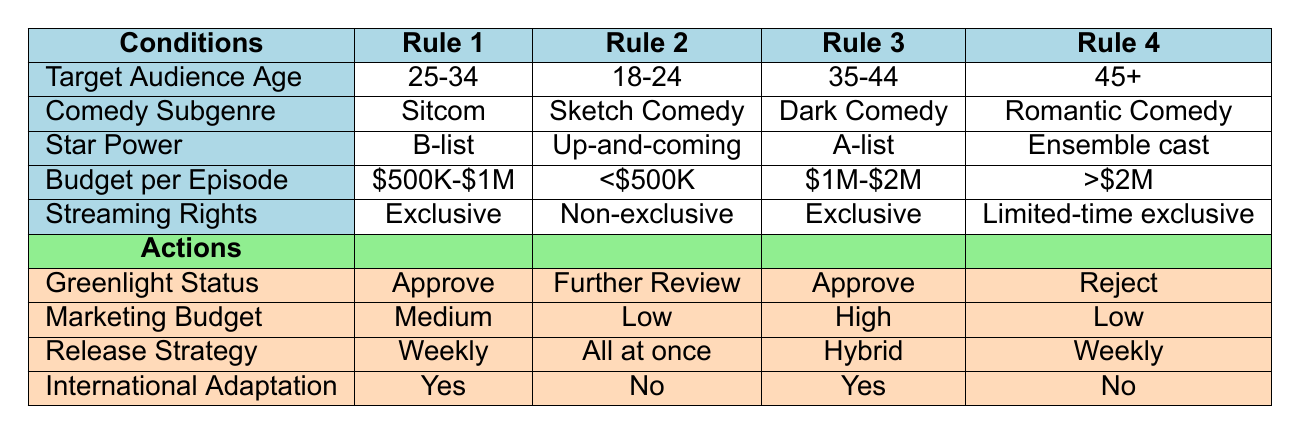What is the greenlight status for the sitcom targeted at the 25-34 age group? According to the table, the sitcom for the 25-34 target age group has a greenlight status of "Approve."
Answer: Approve What is the marketing budget for the comedy series aimed at the 35-44 age group with an A-list star? The table indicates that the marketing budget for the comedy series aimed at the 35-44 age group, which is a dark comedy with A-list star power, is categorized as "High."
Answer: High Is there an international adaptation planned for the romantic comedy targeted at the 45+ age group? The table shows that there is "No" planned international adaptation for the romantic comedy aimed at the 45+ age group.
Answer: No How many comedy series have a greenlight status of "Further Review"? Analyzing the table, there is only one comedy series that has a greenlight status of "Further Review," which is the sketch comedy targeting the 18-24 age group.
Answer: 1 What is the average budget per episode for the approved comedy series? There are two approved comedy series: one with a budget of $500K-$1M and the other with a budget of $1M-$2M. We can compute the average as follows: ($500K-$1M) averages to $750K, and ($1M-$2M) averages to $1.5M, leading to (750K + 1500K) / 2 = $1.125M.
Answer: $1.125M What is the release strategy for comedy series with exclusive streaming rights? The table indicates that both approved series with exclusive streaming rights have release strategies of "Weekly" for the sitcom and "Hybrid" for the dark comedy.
Answer: Weekly and Hybrid What is the star power of the comedy series that has a marketing budget labeled as "Low"? The comedy series with a marketing budget labeled as "Low" is the sketch comedy targeted at the 18-24 age group featuring up-and-coming stars.
Answer: Up-and-coming Are there any comedy series in the table that have budgets greater than $2M? Yes, the comedic series targeted at the 45+ age group, labeled as a romantic comedy, has a budget greater than $2M.
Answer: Yes What specific comedy subgenre is associated with the marketing budget of "Medium"? The comedy subgenre associated with a "Medium" marketing budget is the sitcom targeted at the 25-34 age group.
Answer: Sitcom 